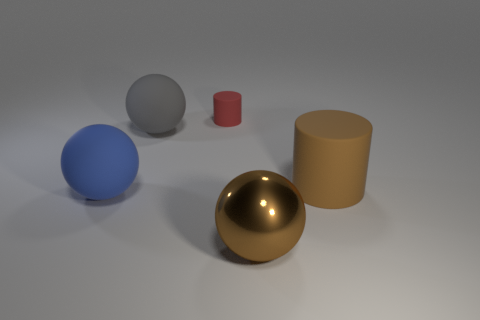Add 5 small gray shiny objects. How many objects exist? 10 Subtract all spheres. How many objects are left? 2 Subtract 0 blue blocks. How many objects are left? 5 Subtract all blue things. Subtract all large cyan matte things. How many objects are left? 4 Add 4 gray matte spheres. How many gray matte spheres are left? 5 Add 5 small balls. How many small balls exist? 5 